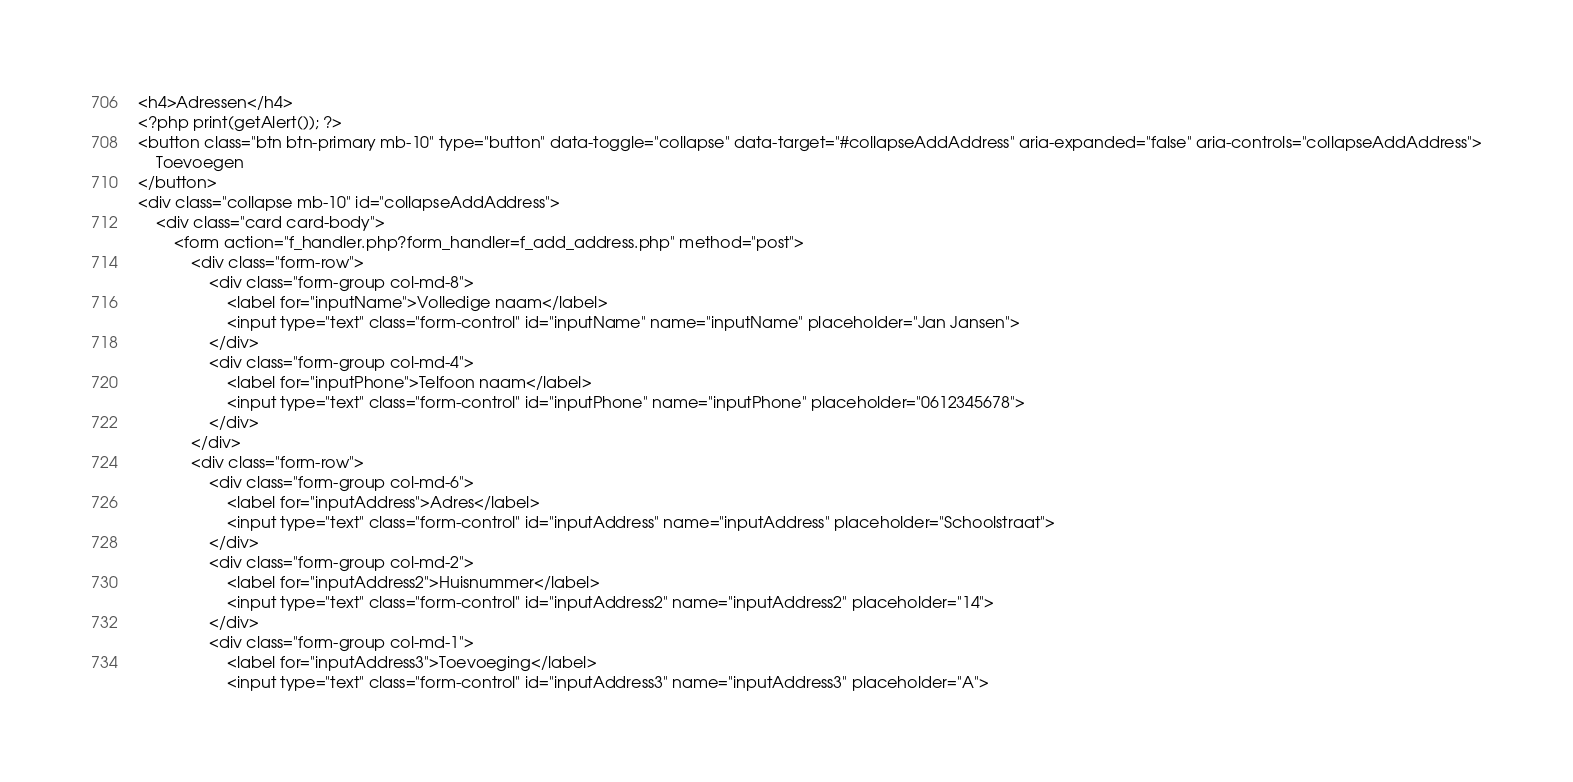Convert code to text. <code><loc_0><loc_0><loc_500><loc_500><_PHP_><h4>Adressen</h4>
<?php print(getAlert()); ?>
<button class="btn btn-primary mb-10" type="button" data-toggle="collapse" data-target="#collapseAddAddress" aria-expanded="false" aria-controls="collapseAddAddress">
    Toevoegen
</button>
<div class="collapse mb-10" id="collapseAddAddress">
    <div class="card card-body">
        <form action="f_handler.php?form_handler=f_add_address.php" method="post">
            <div class="form-row">
                <div class="form-group col-md-8">
                    <label for="inputName">Volledige naam</label>
                    <input type="text" class="form-control" id="inputName" name="inputName" placeholder="Jan Jansen">
                </div>
                <div class="form-group col-md-4">
                    <label for="inputPhone">Telfoon naam</label>
                    <input type="text" class="form-control" id="inputPhone" name="inputPhone" placeholder="0612345678">
                </div>
            </div>
            <div class="form-row">
                <div class="form-group col-md-6">
                    <label for="inputAddress">Adres</label>
                    <input type="text" class="form-control" id="inputAddress" name="inputAddress" placeholder="Schoolstraat">
                </div>
                <div class="form-group col-md-2">
                    <label for="inputAddress2">Huisnummer</label>
                    <input type="text" class="form-control" id="inputAddress2" name="inputAddress2" placeholder="14">
                </div>
                <div class="form-group col-md-1">
                    <label for="inputAddress3">Toevoeging</label>
                    <input type="text" class="form-control" id="inputAddress3" name="inputAddress3" placeholder="A"></code> 